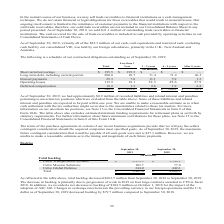According to Cubic's financial document, What is the change in total backlog in 2019? decreased $663.5 million. The document states: "As reflected in the table above, total backlog decreased $663.5 million from September 30, 2018 to September 30, 2019. The decrease in backlog is prim..." Also, What led to the decrease in backlog? The document shows two values: primarily due to progression of work in 2019 on four large contracts awarded to CTS in fiscal 2018 and impact of the adoption of ASC 606. From the document: "klog of $104.5 million on October 1, 2018 for the impact of the adoption of ASC 606. Changes in exchange rates between the prevailing currency in our ..." Also, What are the segments under Total Backlog in the table? The document contains multiple relevant values: Cubic Transportation Systems, Cubic Mission Solutions, Cubic Global Defense. From the document: "Cubic Mission Solutions 103.7 77.0 Cubic Global Defense 344.0 442.6 Total $ 3,401.0 $ 4,064.5 Cubic Transportation Systems $ 2,953.3 $ 3,544.9..." Also, How many segments are there under Total Backlog? Counting the relevant items in the document: Cubic Transportation Systems, Cubic Mission Solutions, Cubic Global Defense, I find 3 instances. The key data points involved are: Cubic Global Defense, Cubic Mission Solutions, Cubic Transportation Systems. Also, can you calculate: What is the change in the backlog for Cubic Mission Solutions in 2019? Based on the calculation: 103.7-77, the result is 26.7 (in millions). This is based on the information: "Cubic Mission Solutions 103.7 77.0 Cubic Mission Solutions 103.7 77.0..." The key data points involved are: 103.7, 77. Also, can you calculate: What is the percentage change in the backlog for Cubic Mission Solutions in 2019? To answer this question, I need to perform calculations using the financial data. The calculation is: (103.7-77)/77, which equals 34.68 (percentage). This is based on the information: "Cubic Mission Solutions 103.7 77.0 Cubic Mission Solutions 103.7 77.0..." The key data points involved are: 103.7, 77. 